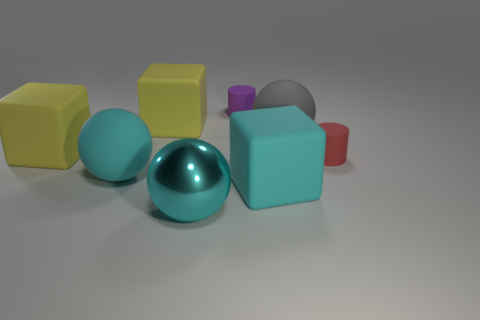Subtract all cyan balls. How many balls are left? 1 Subtract 1 cylinders. How many cylinders are left? 1 Subtract all yellow cubes. How many cubes are left? 1 Add 1 yellow metal blocks. How many objects exist? 9 Add 6 yellow cubes. How many yellow cubes exist? 8 Subtract 0 gray cubes. How many objects are left? 8 Subtract all cylinders. How many objects are left? 6 Subtract all purple cubes. Subtract all red balls. How many cubes are left? 3 Subtract all yellow blocks. How many blue cylinders are left? 0 Subtract all rubber objects. Subtract all big metal balls. How many objects are left? 0 